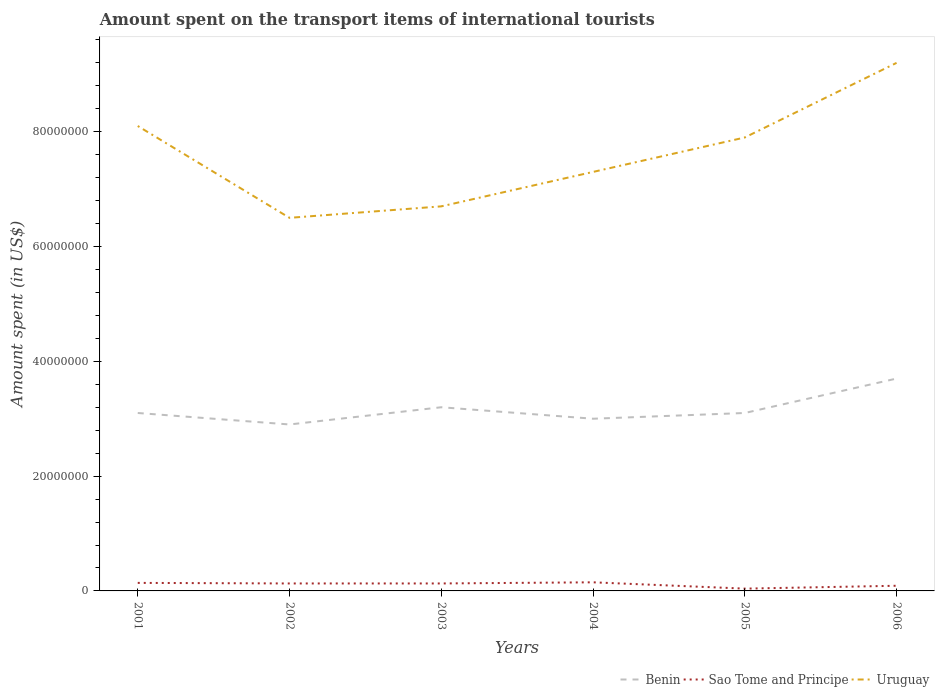How many different coloured lines are there?
Give a very brief answer. 3. Does the line corresponding to Uruguay intersect with the line corresponding to Benin?
Ensure brevity in your answer.  No. Is the number of lines equal to the number of legend labels?
Make the answer very short. Yes. Across all years, what is the maximum amount spent on the transport items of international tourists in Benin?
Make the answer very short. 2.90e+07. In which year was the amount spent on the transport items of international tourists in Sao Tome and Principe maximum?
Keep it short and to the point. 2005. What is the total amount spent on the transport items of international tourists in Benin in the graph?
Provide a succinct answer. 2.00e+06. What is the difference between the highest and the second highest amount spent on the transport items of international tourists in Sao Tome and Principe?
Make the answer very short. 1.10e+06. Is the amount spent on the transport items of international tourists in Benin strictly greater than the amount spent on the transport items of international tourists in Uruguay over the years?
Give a very brief answer. Yes. How many lines are there?
Your answer should be very brief. 3. Are the values on the major ticks of Y-axis written in scientific E-notation?
Offer a very short reply. No. Does the graph contain any zero values?
Your response must be concise. No. How many legend labels are there?
Keep it short and to the point. 3. What is the title of the graph?
Offer a very short reply. Amount spent on the transport items of international tourists. What is the label or title of the X-axis?
Make the answer very short. Years. What is the label or title of the Y-axis?
Keep it short and to the point. Amount spent (in US$). What is the Amount spent (in US$) of Benin in 2001?
Provide a short and direct response. 3.10e+07. What is the Amount spent (in US$) in Sao Tome and Principe in 2001?
Keep it short and to the point. 1.40e+06. What is the Amount spent (in US$) of Uruguay in 2001?
Make the answer very short. 8.10e+07. What is the Amount spent (in US$) in Benin in 2002?
Provide a succinct answer. 2.90e+07. What is the Amount spent (in US$) in Sao Tome and Principe in 2002?
Your answer should be very brief. 1.30e+06. What is the Amount spent (in US$) of Uruguay in 2002?
Your answer should be compact. 6.50e+07. What is the Amount spent (in US$) in Benin in 2003?
Offer a very short reply. 3.20e+07. What is the Amount spent (in US$) in Sao Tome and Principe in 2003?
Ensure brevity in your answer.  1.30e+06. What is the Amount spent (in US$) of Uruguay in 2003?
Offer a terse response. 6.70e+07. What is the Amount spent (in US$) of Benin in 2004?
Ensure brevity in your answer.  3.00e+07. What is the Amount spent (in US$) in Sao Tome and Principe in 2004?
Offer a terse response. 1.50e+06. What is the Amount spent (in US$) of Uruguay in 2004?
Keep it short and to the point. 7.30e+07. What is the Amount spent (in US$) of Benin in 2005?
Keep it short and to the point. 3.10e+07. What is the Amount spent (in US$) in Uruguay in 2005?
Offer a terse response. 7.90e+07. What is the Amount spent (in US$) of Benin in 2006?
Offer a very short reply. 3.70e+07. What is the Amount spent (in US$) in Uruguay in 2006?
Ensure brevity in your answer.  9.20e+07. Across all years, what is the maximum Amount spent (in US$) of Benin?
Make the answer very short. 3.70e+07. Across all years, what is the maximum Amount spent (in US$) in Sao Tome and Principe?
Your answer should be compact. 1.50e+06. Across all years, what is the maximum Amount spent (in US$) in Uruguay?
Provide a short and direct response. 9.20e+07. Across all years, what is the minimum Amount spent (in US$) in Benin?
Offer a very short reply. 2.90e+07. Across all years, what is the minimum Amount spent (in US$) of Uruguay?
Make the answer very short. 6.50e+07. What is the total Amount spent (in US$) of Benin in the graph?
Offer a very short reply. 1.90e+08. What is the total Amount spent (in US$) of Sao Tome and Principe in the graph?
Your response must be concise. 6.80e+06. What is the total Amount spent (in US$) in Uruguay in the graph?
Your response must be concise. 4.57e+08. What is the difference between the Amount spent (in US$) of Sao Tome and Principe in 2001 and that in 2002?
Provide a succinct answer. 1.00e+05. What is the difference between the Amount spent (in US$) of Uruguay in 2001 and that in 2002?
Provide a short and direct response. 1.60e+07. What is the difference between the Amount spent (in US$) in Benin in 2001 and that in 2003?
Offer a terse response. -1.00e+06. What is the difference between the Amount spent (in US$) in Uruguay in 2001 and that in 2003?
Keep it short and to the point. 1.40e+07. What is the difference between the Amount spent (in US$) of Benin in 2001 and that in 2004?
Provide a succinct answer. 1.00e+06. What is the difference between the Amount spent (in US$) of Benin in 2001 and that in 2005?
Your answer should be very brief. 0. What is the difference between the Amount spent (in US$) of Sao Tome and Principe in 2001 and that in 2005?
Provide a short and direct response. 1.00e+06. What is the difference between the Amount spent (in US$) of Uruguay in 2001 and that in 2005?
Provide a succinct answer. 2.00e+06. What is the difference between the Amount spent (in US$) of Benin in 2001 and that in 2006?
Your response must be concise. -6.00e+06. What is the difference between the Amount spent (in US$) in Uruguay in 2001 and that in 2006?
Keep it short and to the point. -1.10e+07. What is the difference between the Amount spent (in US$) in Benin in 2002 and that in 2003?
Offer a very short reply. -3.00e+06. What is the difference between the Amount spent (in US$) of Uruguay in 2002 and that in 2003?
Keep it short and to the point. -2.00e+06. What is the difference between the Amount spent (in US$) of Uruguay in 2002 and that in 2004?
Your answer should be very brief. -8.00e+06. What is the difference between the Amount spent (in US$) of Benin in 2002 and that in 2005?
Your answer should be very brief. -2.00e+06. What is the difference between the Amount spent (in US$) in Sao Tome and Principe in 2002 and that in 2005?
Offer a terse response. 9.00e+05. What is the difference between the Amount spent (in US$) in Uruguay in 2002 and that in 2005?
Provide a succinct answer. -1.40e+07. What is the difference between the Amount spent (in US$) in Benin in 2002 and that in 2006?
Give a very brief answer. -8.00e+06. What is the difference between the Amount spent (in US$) of Uruguay in 2002 and that in 2006?
Your response must be concise. -2.70e+07. What is the difference between the Amount spent (in US$) in Uruguay in 2003 and that in 2004?
Make the answer very short. -6.00e+06. What is the difference between the Amount spent (in US$) of Benin in 2003 and that in 2005?
Give a very brief answer. 1.00e+06. What is the difference between the Amount spent (in US$) of Sao Tome and Principe in 2003 and that in 2005?
Keep it short and to the point. 9.00e+05. What is the difference between the Amount spent (in US$) of Uruguay in 2003 and that in 2005?
Your answer should be very brief. -1.20e+07. What is the difference between the Amount spent (in US$) of Benin in 2003 and that in 2006?
Give a very brief answer. -5.00e+06. What is the difference between the Amount spent (in US$) of Uruguay in 2003 and that in 2006?
Your response must be concise. -2.50e+07. What is the difference between the Amount spent (in US$) of Benin in 2004 and that in 2005?
Your answer should be very brief. -1.00e+06. What is the difference between the Amount spent (in US$) in Sao Tome and Principe in 2004 and that in 2005?
Give a very brief answer. 1.10e+06. What is the difference between the Amount spent (in US$) of Uruguay in 2004 and that in 2005?
Make the answer very short. -6.00e+06. What is the difference between the Amount spent (in US$) of Benin in 2004 and that in 2006?
Provide a succinct answer. -7.00e+06. What is the difference between the Amount spent (in US$) in Sao Tome and Principe in 2004 and that in 2006?
Offer a terse response. 6.00e+05. What is the difference between the Amount spent (in US$) in Uruguay in 2004 and that in 2006?
Ensure brevity in your answer.  -1.90e+07. What is the difference between the Amount spent (in US$) in Benin in 2005 and that in 2006?
Offer a terse response. -6.00e+06. What is the difference between the Amount spent (in US$) of Sao Tome and Principe in 2005 and that in 2006?
Offer a terse response. -5.00e+05. What is the difference between the Amount spent (in US$) of Uruguay in 2005 and that in 2006?
Offer a very short reply. -1.30e+07. What is the difference between the Amount spent (in US$) in Benin in 2001 and the Amount spent (in US$) in Sao Tome and Principe in 2002?
Offer a terse response. 2.97e+07. What is the difference between the Amount spent (in US$) of Benin in 2001 and the Amount spent (in US$) of Uruguay in 2002?
Keep it short and to the point. -3.40e+07. What is the difference between the Amount spent (in US$) in Sao Tome and Principe in 2001 and the Amount spent (in US$) in Uruguay in 2002?
Keep it short and to the point. -6.36e+07. What is the difference between the Amount spent (in US$) of Benin in 2001 and the Amount spent (in US$) of Sao Tome and Principe in 2003?
Offer a very short reply. 2.97e+07. What is the difference between the Amount spent (in US$) in Benin in 2001 and the Amount spent (in US$) in Uruguay in 2003?
Your answer should be compact. -3.60e+07. What is the difference between the Amount spent (in US$) in Sao Tome and Principe in 2001 and the Amount spent (in US$) in Uruguay in 2003?
Your answer should be compact. -6.56e+07. What is the difference between the Amount spent (in US$) in Benin in 2001 and the Amount spent (in US$) in Sao Tome and Principe in 2004?
Give a very brief answer. 2.95e+07. What is the difference between the Amount spent (in US$) in Benin in 2001 and the Amount spent (in US$) in Uruguay in 2004?
Your response must be concise. -4.20e+07. What is the difference between the Amount spent (in US$) of Sao Tome and Principe in 2001 and the Amount spent (in US$) of Uruguay in 2004?
Make the answer very short. -7.16e+07. What is the difference between the Amount spent (in US$) of Benin in 2001 and the Amount spent (in US$) of Sao Tome and Principe in 2005?
Your response must be concise. 3.06e+07. What is the difference between the Amount spent (in US$) of Benin in 2001 and the Amount spent (in US$) of Uruguay in 2005?
Keep it short and to the point. -4.80e+07. What is the difference between the Amount spent (in US$) of Sao Tome and Principe in 2001 and the Amount spent (in US$) of Uruguay in 2005?
Your answer should be compact. -7.76e+07. What is the difference between the Amount spent (in US$) in Benin in 2001 and the Amount spent (in US$) in Sao Tome and Principe in 2006?
Provide a succinct answer. 3.01e+07. What is the difference between the Amount spent (in US$) of Benin in 2001 and the Amount spent (in US$) of Uruguay in 2006?
Give a very brief answer. -6.10e+07. What is the difference between the Amount spent (in US$) of Sao Tome and Principe in 2001 and the Amount spent (in US$) of Uruguay in 2006?
Provide a succinct answer. -9.06e+07. What is the difference between the Amount spent (in US$) in Benin in 2002 and the Amount spent (in US$) in Sao Tome and Principe in 2003?
Provide a succinct answer. 2.77e+07. What is the difference between the Amount spent (in US$) in Benin in 2002 and the Amount spent (in US$) in Uruguay in 2003?
Keep it short and to the point. -3.80e+07. What is the difference between the Amount spent (in US$) of Sao Tome and Principe in 2002 and the Amount spent (in US$) of Uruguay in 2003?
Your response must be concise. -6.57e+07. What is the difference between the Amount spent (in US$) of Benin in 2002 and the Amount spent (in US$) of Sao Tome and Principe in 2004?
Keep it short and to the point. 2.75e+07. What is the difference between the Amount spent (in US$) of Benin in 2002 and the Amount spent (in US$) of Uruguay in 2004?
Keep it short and to the point. -4.40e+07. What is the difference between the Amount spent (in US$) of Sao Tome and Principe in 2002 and the Amount spent (in US$) of Uruguay in 2004?
Make the answer very short. -7.17e+07. What is the difference between the Amount spent (in US$) in Benin in 2002 and the Amount spent (in US$) in Sao Tome and Principe in 2005?
Give a very brief answer. 2.86e+07. What is the difference between the Amount spent (in US$) of Benin in 2002 and the Amount spent (in US$) of Uruguay in 2005?
Ensure brevity in your answer.  -5.00e+07. What is the difference between the Amount spent (in US$) in Sao Tome and Principe in 2002 and the Amount spent (in US$) in Uruguay in 2005?
Make the answer very short. -7.77e+07. What is the difference between the Amount spent (in US$) of Benin in 2002 and the Amount spent (in US$) of Sao Tome and Principe in 2006?
Your response must be concise. 2.81e+07. What is the difference between the Amount spent (in US$) in Benin in 2002 and the Amount spent (in US$) in Uruguay in 2006?
Make the answer very short. -6.30e+07. What is the difference between the Amount spent (in US$) of Sao Tome and Principe in 2002 and the Amount spent (in US$) of Uruguay in 2006?
Your answer should be very brief. -9.07e+07. What is the difference between the Amount spent (in US$) of Benin in 2003 and the Amount spent (in US$) of Sao Tome and Principe in 2004?
Your answer should be compact. 3.05e+07. What is the difference between the Amount spent (in US$) in Benin in 2003 and the Amount spent (in US$) in Uruguay in 2004?
Your answer should be compact. -4.10e+07. What is the difference between the Amount spent (in US$) of Sao Tome and Principe in 2003 and the Amount spent (in US$) of Uruguay in 2004?
Your response must be concise. -7.17e+07. What is the difference between the Amount spent (in US$) in Benin in 2003 and the Amount spent (in US$) in Sao Tome and Principe in 2005?
Make the answer very short. 3.16e+07. What is the difference between the Amount spent (in US$) of Benin in 2003 and the Amount spent (in US$) of Uruguay in 2005?
Give a very brief answer. -4.70e+07. What is the difference between the Amount spent (in US$) of Sao Tome and Principe in 2003 and the Amount spent (in US$) of Uruguay in 2005?
Provide a succinct answer. -7.77e+07. What is the difference between the Amount spent (in US$) of Benin in 2003 and the Amount spent (in US$) of Sao Tome and Principe in 2006?
Offer a very short reply. 3.11e+07. What is the difference between the Amount spent (in US$) in Benin in 2003 and the Amount spent (in US$) in Uruguay in 2006?
Your answer should be compact. -6.00e+07. What is the difference between the Amount spent (in US$) of Sao Tome and Principe in 2003 and the Amount spent (in US$) of Uruguay in 2006?
Ensure brevity in your answer.  -9.07e+07. What is the difference between the Amount spent (in US$) of Benin in 2004 and the Amount spent (in US$) of Sao Tome and Principe in 2005?
Offer a very short reply. 2.96e+07. What is the difference between the Amount spent (in US$) in Benin in 2004 and the Amount spent (in US$) in Uruguay in 2005?
Offer a very short reply. -4.90e+07. What is the difference between the Amount spent (in US$) of Sao Tome and Principe in 2004 and the Amount spent (in US$) of Uruguay in 2005?
Make the answer very short. -7.75e+07. What is the difference between the Amount spent (in US$) of Benin in 2004 and the Amount spent (in US$) of Sao Tome and Principe in 2006?
Keep it short and to the point. 2.91e+07. What is the difference between the Amount spent (in US$) of Benin in 2004 and the Amount spent (in US$) of Uruguay in 2006?
Offer a terse response. -6.20e+07. What is the difference between the Amount spent (in US$) in Sao Tome and Principe in 2004 and the Amount spent (in US$) in Uruguay in 2006?
Make the answer very short. -9.05e+07. What is the difference between the Amount spent (in US$) in Benin in 2005 and the Amount spent (in US$) in Sao Tome and Principe in 2006?
Make the answer very short. 3.01e+07. What is the difference between the Amount spent (in US$) of Benin in 2005 and the Amount spent (in US$) of Uruguay in 2006?
Your answer should be very brief. -6.10e+07. What is the difference between the Amount spent (in US$) of Sao Tome and Principe in 2005 and the Amount spent (in US$) of Uruguay in 2006?
Offer a very short reply. -9.16e+07. What is the average Amount spent (in US$) in Benin per year?
Provide a succinct answer. 3.17e+07. What is the average Amount spent (in US$) of Sao Tome and Principe per year?
Your answer should be very brief. 1.13e+06. What is the average Amount spent (in US$) in Uruguay per year?
Keep it short and to the point. 7.62e+07. In the year 2001, what is the difference between the Amount spent (in US$) of Benin and Amount spent (in US$) of Sao Tome and Principe?
Offer a very short reply. 2.96e+07. In the year 2001, what is the difference between the Amount spent (in US$) in Benin and Amount spent (in US$) in Uruguay?
Your answer should be very brief. -5.00e+07. In the year 2001, what is the difference between the Amount spent (in US$) in Sao Tome and Principe and Amount spent (in US$) in Uruguay?
Keep it short and to the point. -7.96e+07. In the year 2002, what is the difference between the Amount spent (in US$) of Benin and Amount spent (in US$) of Sao Tome and Principe?
Your response must be concise. 2.77e+07. In the year 2002, what is the difference between the Amount spent (in US$) in Benin and Amount spent (in US$) in Uruguay?
Provide a short and direct response. -3.60e+07. In the year 2002, what is the difference between the Amount spent (in US$) of Sao Tome and Principe and Amount spent (in US$) of Uruguay?
Your response must be concise. -6.37e+07. In the year 2003, what is the difference between the Amount spent (in US$) of Benin and Amount spent (in US$) of Sao Tome and Principe?
Provide a succinct answer. 3.07e+07. In the year 2003, what is the difference between the Amount spent (in US$) in Benin and Amount spent (in US$) in Uruguay?
Give a very brief answer. -3.50e+07. In the year 2003, what is the difference between the Amount spent (in US$) in Sao Tome and Principe and Amount spent (in US$) in Uruguay?
Ensure brevity in your answer.  -6.57e+07. In the year 2004, what is the difference between the Amount spent (in US$) in Benin and Amount spent (in US$) in Sao Tome and Principe?
Ensure brevity in your answer.  2.85e+07. In the year 2004, what is the difference between the Amount spent (in US$) of Benin and Amount spent (in US$) of Uruguay?
Keep it short and to the point. -4.30e+07. In the year 2004, what is the difference between the Amount spent (in US$) of Sao Tome and Principe and Amount spent (in US$) of Uruguay?
Give a very brief answer. -7.15e+07. In the year 2005, what is the difference between the Amount spent (in US$) in Benin and Amount spent (in US$) in Sao Tome and Principe?
Keep it short and to the point. 3.06e+07. In the year 2005, what is the difference between the Amount spent (in US$) in Benin and Amount spent (in US$) in Uruguay?
Keep it short and to the point. -4.80e+07. In the year 2005, what is the difference between the Amount spent (in US$) of Sao Tome and Principe and Amount spent (in US$) of Uruguay?
Keep it short and to the point. -7.86e+07. In the year 2006, what is the difference between the Amount spent (in US$) of Benin and Amount spent (in US$) of Sao Tome and Principe?
Offer a terse response. 3.61e+07. In the year 2006, what is the difference between the Amount spent (in US$) of Benin and Amount spent (in US$) of Uruguay?
Keep it short and to the point. -5.50e+07. In the year 2006, what is the difference between the Amount spent (in US$) of Sao Tome and Principe and Amount spent (in US$) of Uruguay?
Offer a very short reply. -9.11e+07. What is the ratio of the Amount spent (in US$) in Benin in 2001 to that in 2002?
Make the answer very short. 1.07. What is the ratio of the Amount spent (in US$) in Sao Tome and Principe in 2001 to that in 2002?
Give a very brief answer. 1.08. What is the ratio of the Amount spent (in US$) in Uruguay in 2001 to that in 2002?
Your answer should be compact. 1.25. What is the ratio of the Amount spent (in US$) in Benin in 2001 to that in 2003?
Ensure brevity in your answer.  0.97. What is the ratio of the Amount spent (in US$) in Uruguay in 2001 to that in 2003?
Your response must be concise. 1.21. What is the ratio of the Amount spent (in US$) of Benin in 2001 to that in 2004?
Ensure brevity in your answer.  1.03. What is the ratio of the Amount spent (in US$) of Uruguay in 2001 to that in 2004?
Give a very brief answer. 1.11. What is the ratio of the Amount spent (in US$) in Benin in 2001 to that in 2005?
Offer a terse response. 1. What is the ratio of the Amount spent (in US$) of Sao Tome and Principe in 2001 to that in 2005?
Your answer should be compact. 3.5. What is the ratio of the Amount spent (in US$) in Uruguay in 2001 to that in 2005?
Offer a very short reply. 1.03. What is the ratio of the Amount spent (in US$) of Benin in 2001 to that in 2006?
Give a very brief answer. 0.84. What is the ratio of the Amount spent (in US$) of Sao Tome and Principe in 2001 to that in 2006?
Make the answer very short. 1.56. What is the ratio of the Amount spent (in US$) in Uruguay in 2001 to that in 2006?
Make the answer very short. 0.88. What is the ratio of the Amount spent (in US$) of Benin in 2002 to that in 2003?
Your answer should be compact. 0.91. What is the ratio of the Amount spent (in US$) of Uruguay in 2002 to that in 2003?
Provide a succinct answer. 0.97. What is the ratio of the Amount spent (in US$) of Benin in 2002 to that in 2004?
Keep it short and to the point. 0.97. What is the ratio of the Amount spent (in US$) in Sao Tome and Principe in 2002 to that in 2004?
Offer a very short reply. 0.87. What is the ratio of the Amount spent (in US$) of Uruguay in 2002 to that in 2004?
Your answer should be compact. 0.89. What is the ratio of the Amount spent (in US$) of Benin in 2002 to that in 2005?
Provide a succinct answer. 0.94. What is the ratio of the Amount spent (in US$) of Uruguay in 2002 to that in 2005?
Your response must be concise. 0.82. What is the ratio of the Amount spent (in US$) in Benin in 2002 to that in 2006?
Provide a succinct answer. 0.78. What is the ratio of the Amount spent (in US$) of Sao Tome and Principe in 2002 to that in 2006?
Offer a very short reply. 1.44. What is the ratio of the Amount spent (in US$) in Uruguay in 2002 to that in 2006?
Provide a succinct answer. 0.71. What is the ratio of the Amount spent (in US$) of Benin in 2003 to that in 2004?
Your answer should be very brief. 1.07. What is the ratio of the Amount spent (in US$) in Sao Tome and Principe in 2003 to that in 2004?
Provide a short and direct response. 0.87. What is the ratio of the Amount spent (in US$) of Uruguay in 2003 to that in 2004?
Provide a succinct answer. 0.92. What is the ratio of the Amount spent (in US$) of Benin in 2003 to that in 2005?
Provide a succinct answer. 1.03. What is the ratio of the Amount spent (in US$) in Sao Tome and Principe in 2003 to that in 2005?
Ensure brevity in your answer.  3.25. What is the ratio of the Amount spent (in US$) in Uruguay in 2003 to that in 2005?
Your response must be concise. 0.85. What is the ratio of the Amount spent (in US$) in Benin in 2003 to that in 2006?
Provide a succinct answer. 0.86. What is the ratio of the Amount spent (in US$) in Sao Tome and Principe in 2003 to that in 2006?
Give a very brief answer. 1.44. What is the ratio of the Amount spent (in US$) of Uruguay in 2003 to that in 2006?
Your answer should be very brief. 0.73. What is the ratio of the Amount spent (in US$) in Benin in 2004 to that in 2005?
Your answer should be very brief. 0.97. What is the ratio of the Amount spent (in US$) of Sao Tome and Principe in 2004 to that in 2005?
Keep it short and to the point. 3.75. What is the ratio of the Amount spent (in US$) of Uruguay in 2004 to that in 2005?
Provide a short and direct response. 0.92. What is the ratio of the Amount spent (in US$) in Benin in 2004 to that in 2006?
Make the answer very short. 0.81. What is the ratio of the Amount spent (in US$) of Uruguay in 2004 to that in 2006?
Your answer should be very brief. 0.79. What is the ratio of the Amount spent (in US$) in Benin in 2005 to that in 2006?
Provide a succinct answer. 0.84. What is the ratio of the Amount spent (in US$) in Sao Tome and Principe in 2005 to that in 2006?
Keep it short and to the point. 0.44. What is the ratio of the Amount spent (in US$) in Uruguay in 2005 to that in 2006?
Offer a terse response. 0.86. What is the difference between the highest and the second highest Amount spent (in US$) in Uruguay?
Give a very brief answer. 1.10e+07. What is the difference between the highest and the lowest Amount spent (in US$) of Benin?
Offer a very short reply. 8.00e+06. What is the difference between the highest and the lowest Amount spent (in US$) of Sao Tome and Principe?
Offer a terse response. 1.10e+06. What is the difference between the highest and the lowest Amount spent (in US$) of Uruguay?
Your answer should be compact. 2.70e+07. 